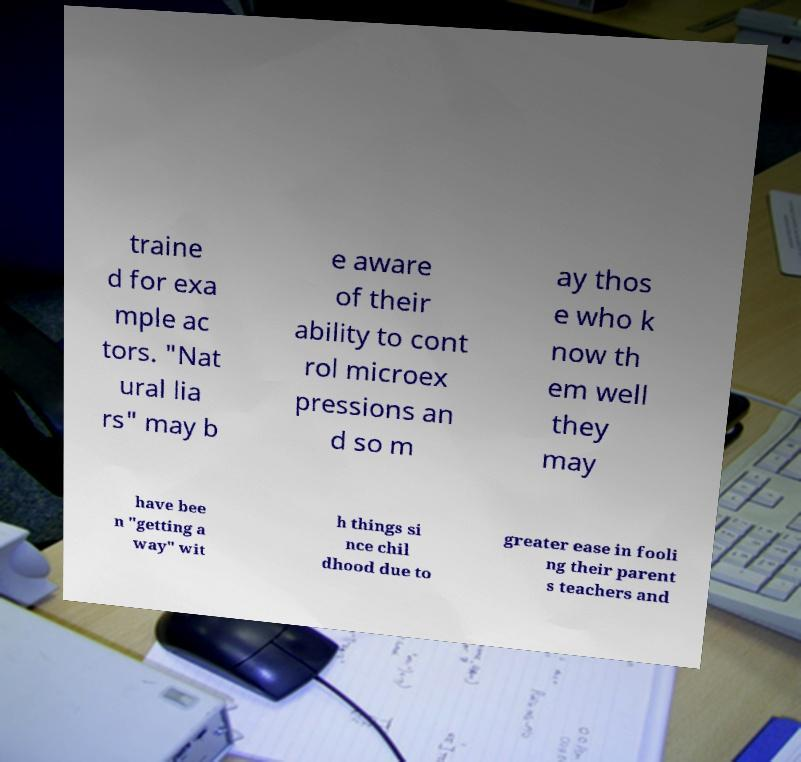Can you accurately transcribe the text from the provided image for me? traine d for exa mple ac tors. "Nat ural lia rs" may b e aware of their ability to cont rol microex pressions an d so m ay thos e who k now th em well they may have bee n "getting a way" wit h things si nce chil dhood due to greater ease in fooli ng their parent s teachers and 